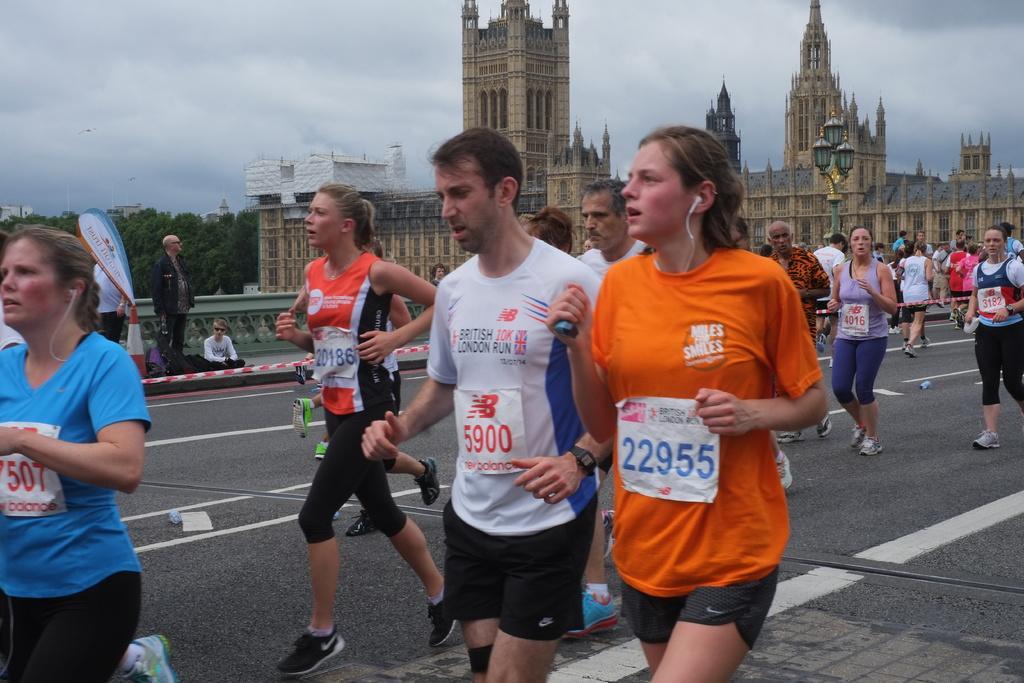How would you summarize this image in a sentence or two? In this picture we can observe some people walking and running on the road. There are men and women. In the background we can observe a building which is in brown color. We can observe trees and a sky with some clouds. 